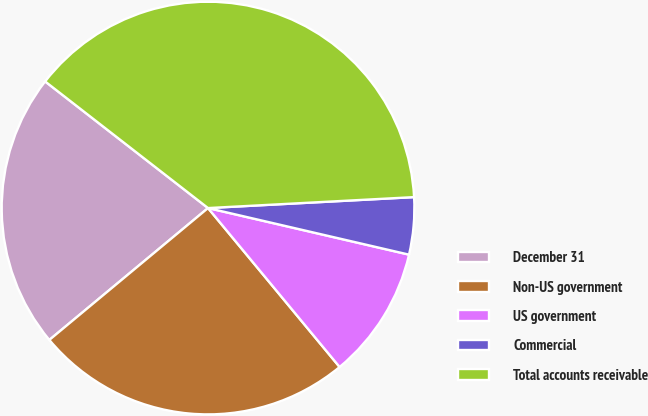<chart> <loc_0><loc_0><loc_500><loc_500><pie_chart><fcel>December 31<fcel>Non-US government<fcel>US government<fcel>Commercial<fcel>Total accounts receivable<nl><fcel>21.55%<fcel>24.97%<fcel>10.37%<fcel>4.47%<fcel>38.64%<nl></chart> 